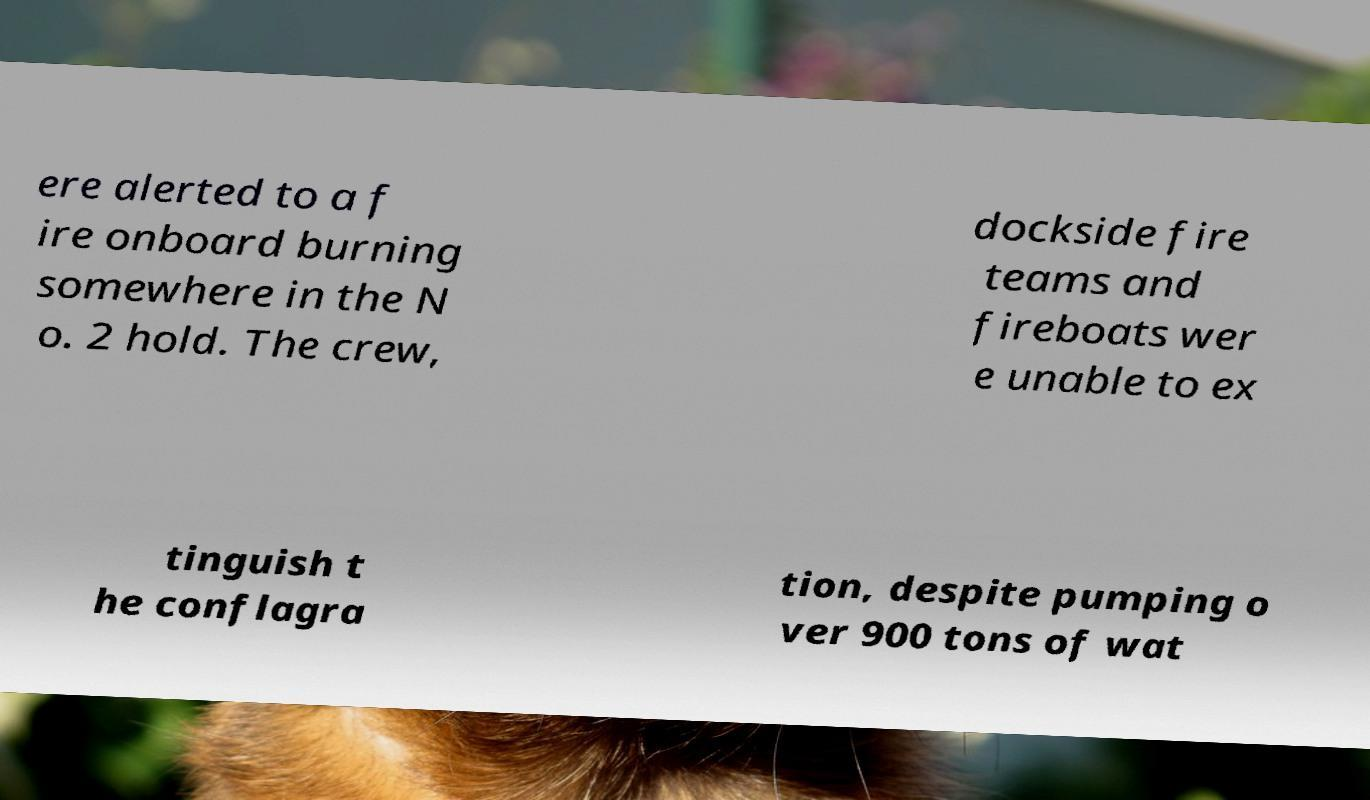Can you read and provide the text displayed in the image?This photo seems to have some interesting text. Can you extract and type it out for me? ere alerted to a f ire onboard burning somewhere in the N o. 2 hold. The crew, dockside fire teams and fireboats wer e unable to ex tinguish t he conflagra tion, despite pumping o ver 900 tons of wat 